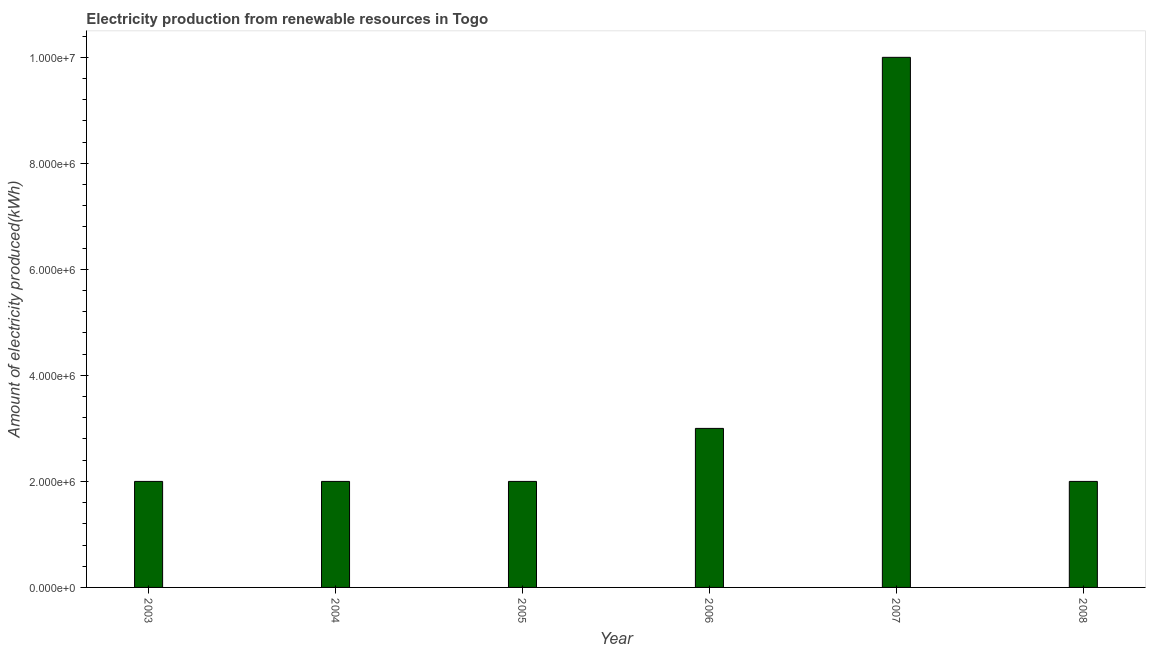What is the title of the graph?
Make the answer very short. Electricity production from renewable resources in Togo. What is the label or title of the Y-axis?
Your answer should be very brief. Amount of electricity produced(kWh). What is the amount of electricity produced in 2004?
Your answer should be very brief. 2.00e+06. In which year was the amount of electricity produced minimum?
Offer a very short reply. 2003. What is the sum of the amount of electricity produced?
Offer a very short reply. 2.10e+07. What is the difference between the amount of electricity produced in 2006 and 2007?
Your answer should be very brief. -7.00e+06. What is the average amount of electricity produced per year?
Ensure brevity in your answer.  3.50e+06. Do a majority of the years between 2007 and 2004 (inclusive) have amount of electricity produced greater than 9200000 kWh?
Give a very brief answer. Yes. What is the ratio of the amount of electricity produced in 2005 to that in 2006?
Your response must be concise. 0.67. Is the amount of electricity produced in 2005 less than that in 2006?
Offer a terse response. Yes. Is the difference between the amount of electricity produced in 2005 and 2008 greater than the difference between any two years?
Ensure brevity in your answer.  No. What is the difference between the highest and the second highest amount of electricity produced?
Give a very brief answer. 7.00e+06. Is the sum of the amount of electricity produced in 2004 and 2006 greater than the maximum amount of electricity produced across all years?
Give a very brief answer. No. What is the difference between the highest and the lowest amount of electricity produced?
Your answer should be compact. 8.00e+06. In how many years, is the amount of electricity produced greater than the average amount of electricity produced taken over all years?
Give a very brief answer. 1. Are all the bars in the graph horizontal?
Offer a terse response. No. What is the difference between two consecutive major ticks on the Y-axis?
Offer a very short reply. 2.00e+06. Are the values on the major ticks of Y-axis written in scientific E-notation?
Provide a succinct answer. Yes. What is the Amount of electricity produced(kWh) in 2005?
Your answer should be very brief. 2.00e+06. What is the Amount of electricity produced(kWh) in 2006?
Give a very brief answer. 3.00e+06. What is the Amount of electricity produced(kWh) in 2007?
Provide a succinct answer. 1.00e+07. What is the difference between the Amount of electricity produced(kWh) in 2003 and 2006?
Make the answer very short. -1.00e+06. What is the difference between the Amount of electricity produced(kWh) in 2003 and 2007?
Offer a terse response. -8.00e+06. What is the difference between the Amount of electricity produced(kWh) in 2003 and 2008?
Keep it short and to the point. 0. What is the difference between the Amount of electricity produced(kWh) in 2004 and 2007?
Your answer should be very brief. -8.00e+06. What is the difference between the Amount of electricity produced(kWh) in 2005 and 2006?
Provide a succinct answer. -1.00e+06. What is the difference between the Amount of electricity produced(kWh) in 2005 and 2007?
Provide a succinct answer. -8.00e+06. What is the difference between the Amount of electricity produced(kWh) in 2006 and 2007?
Provide a succinct answer. -7.00e+06. What is the difference between the Amount of electricity produced(kWh) in 2007 and 2008?
Your response must be concise. 8.00e+06. What is the ratio of the Amount of electricity produced(kWh) in 2003 to that in 2006?
Keep it short and to the point. 0.67. What is the ratio of the Amount of electricity produced(kWh) in 2004 to that in 2005?
Give a very brief answer. 1. What is the ratio of the Amount of electricity produced(kWh) in 2004 to that in 2006?
Provide a short and direct response. 0.67. What is the ratio of the Amount of electricity produced(kWh) in 2005 to that in 2006?
Offer a terse response. 0.67. What is the ratio of the Amount of electricity produced(kWh) in 2005 to that in 2007?
Ensure brevity in your answer.  0.2. 